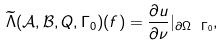<formula> <loc_0><loc_0><loc_500><loc_500>\widetilde { \Lambda } ( \mathcal { A } , \mathcal { B } , Q , \Gamma _ { 0 } ) ( f ) = \frac { \partial u } { \partial \nu } | _ { \partial \Omega \ \Gamma _ { 0 } } ,</formula> 